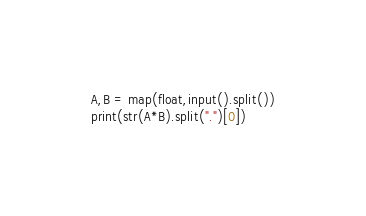Convert code to text. <code><loc_0><loc_0><loc_500><loc_500><_Python_>A,B = map(float,input().split())
print(str(A*B).split(".")[0])</code> 